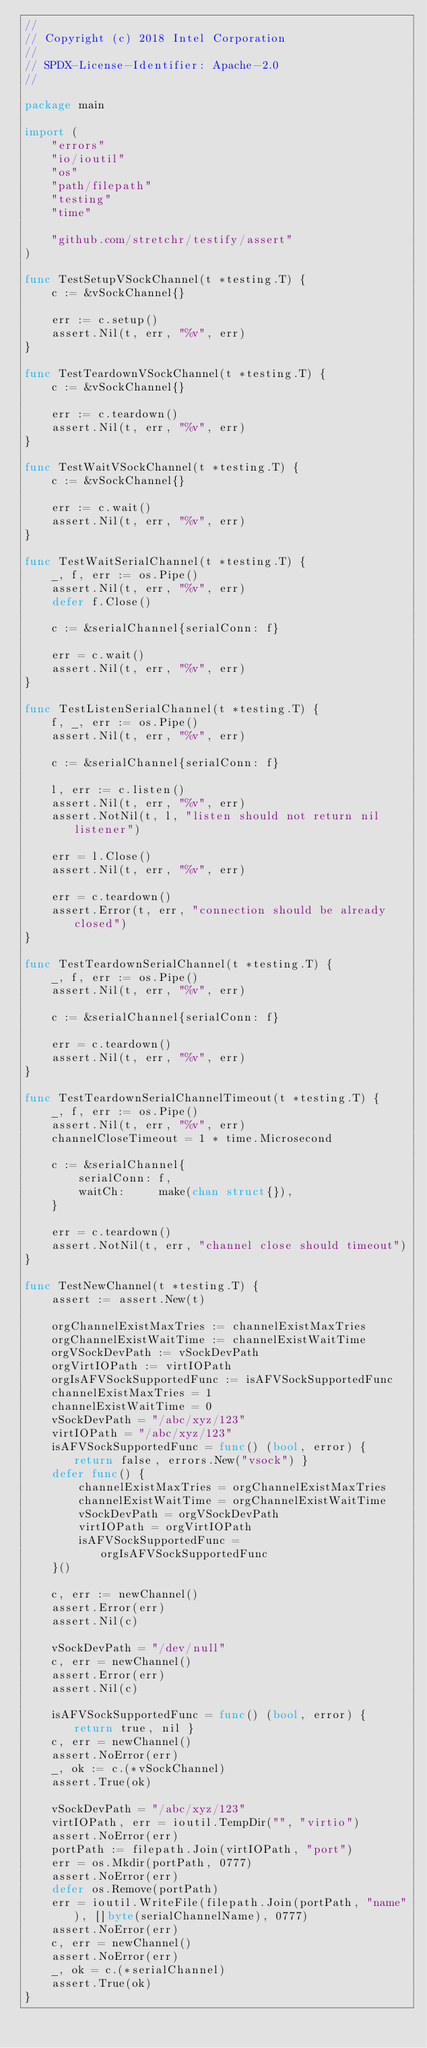<code> <loc_0><loc_0><loc_500><loc_500><_Go_>//
// Copyright (c) 2018 Intel Corporation
//
// SPDX-License-Identifier: Apache-2.0
//

package main

import (
	"errors"
	"io/ioutil"
	"os"
	"path/filepath"
	"testing"
	"time"

	"github.com/stretchr/testify/assert"
)

func TestSetupVSockChannel(t *testing.T) {
	c := &vSockChannel{}

	err := c.setup()
	assert.Nil(t, err, "%v", err)
}

func TestTeardownVSockChannel(t *testing.T) {
	c := &vSockChannel{}

	err := c.teardown()
	assert.Nil(t, err, "%v", err)
}

func TestWaitVSockChannel(t *testing.T) {
	c := &vSockChannel{}

	err := c.wait()
	assert.Nil(t, err, "%v", err)
}

func TestWaitSerialChannel(t *testing.T) {
	_, f, err := os.Pipe()
	assert.Nil(t, err, "%v", err)
	defer f.Close()

	c := &serialChannel{serialConn: f}

	err = c.wait()
	assert.Nil(t, err, "%v", err)
}

func TestListenSerialChannel(t *testing.T) {
	f, _, err := os.Pipe()
	assert.Nil(t, err, "%v", err)

	c := &serialChannel{serialConn: f}

	l, err := c.listen()
	assert.Nil(t, err, "%v", err)
	assert.NotNil(t, l, "listen should not return nil listener")

	err = l.Close()
	assert.Nil(t, err, "%v", err)

	err = c.teardown()
	assert.Error(t, err, "connection should be already closed")
}

func TestTeardownSerialChannel(t *testing.T) {
	_, f, err := os.Pipe()
	assert.Nil(t, err, "%v", err)

	c := &serialChannel{serialConn: f}

	err = c.teardown()
	assert.Nil(t, err, "%v", err)
}

func TestTeardownSerialChannelTimeout(t *testing.T) {
	_, f, err := os.Pipe()
	assert.Nil(t, err, "%v", err)
	channelCloseTimeout = 1 * time.Microsecond

	c := &serialChannel{
		serialConn: f,
		waitCh:     make(chan struct{}),
	}

	err = c.teardown()
	assert.NotNil(t, err, "channel close should timeout")
}

func TestNewChannel(t *testing.T) {
	assert := assert.New(t)

	orgChannelExistMaxTries := channelExistMaxTries
	orgChannelExistWaitTime := channelExistWaitTime
	orgVSockDevPath := vSockDevPath
	orgVirtIOPath := virtIOPath
	orgIsAFVSockSupportedFunc := isAFVSockSupportedFunc
	channelExistMaxTries = 1
	channelExistWaitTime = 0
	vSockDevPath = "/abc/xyz/123"
	virtIOPath = "/abc/xyz/123"
	isAFVSockSupportedFunc = func() (bool, error) { return false, errors.New("vsock") }
	defer func() {
		channelExistMaxTries = orgChannelExistMaxTries
		channelExistWaitTime = orgChannelExistWaitTime
		vSockDevPath = orgVSockDevPath
		virtIOPath = orgVirtIOPath
		isAFVSockSupportedFunc = orgIsAFVSockSupportedFunc
	}()

	c, err := newChannel()
	assert.Error(err)
	assert.Nil(c)

	vSockDevPath = "/dev/null"
	c, err = newChannel()
	assert.Error(err)
	assert.Nil(c)

	isAFVSockSupportedFunc = func() (bool, error) { return true, nil }
	c, err = newChannel()
	assert.NoError(err)
	_, ok := c.(*vSockChannel)
	assert.True(ok)

	vSockDevPath = "/abc/xyz/123"
	virtIOPath, err = ioutil.TempDir("", "virtio")
	assert.NoError(err)
	portPath := filepath.Join(virtIOPath, "port")
	err = os.Mkdir(portPath, 0777)
	assert.NoError(err)
	defer os.Remove(portPath)
	err = ioutil.WriteFile(filepath.Join(portPath, "name"), []byte(serialChannelName), 0777)
	assert.NoError(err)
	c, err = newChannel()
	assert.NoError(err)
	_, ok = c.(*serialChannel)
	assert.True(ok)
}
</code> 